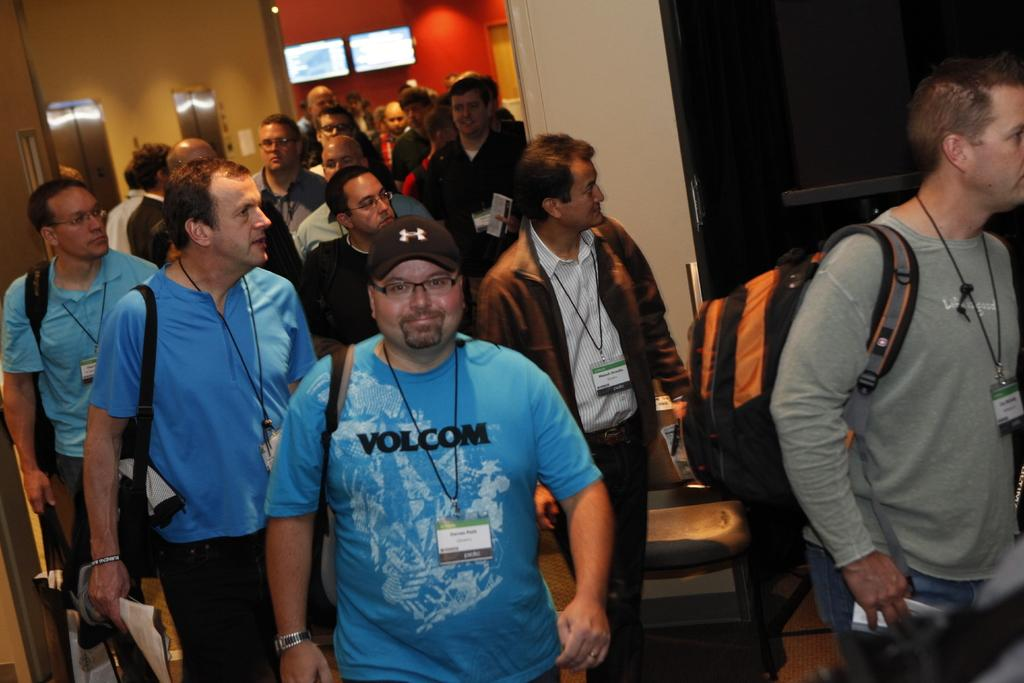What is the main subject of the image? The main subject of the image is a crowd. Where is the crowd located in the image? The crowd is on the floor. What can be seen in the background of the image? There is a wall, doors, and two monitors in the background of the image. What type of location might the image have been taken in? The image may have been taken in a hall. What word is being spelled out by the grass in the image? There is no grass present in the image, and therefore no words can be spelled out by it. 